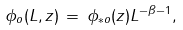Convert formula to latex. <formula><loc_0><loc_0><loc_500><loc_500>\phi _ { o } ( L , z ) \, = \, \phi _ { \ast o } ( z ) L ^ { - \beta - 1 } ,</formula> 